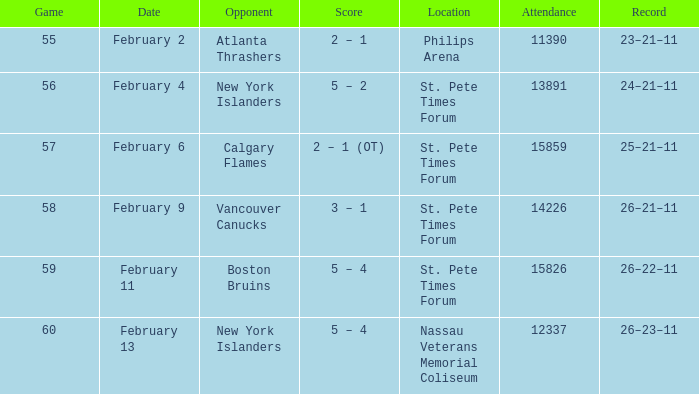What scores happened to be on February 9? 3 – 1. 